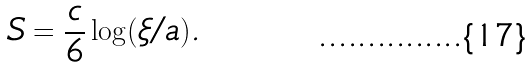<formula> <loc_0><loc_0><loc_500><loc_500>S = \frac { c } { 6 } \log ( \xi / a ) .</formula> 